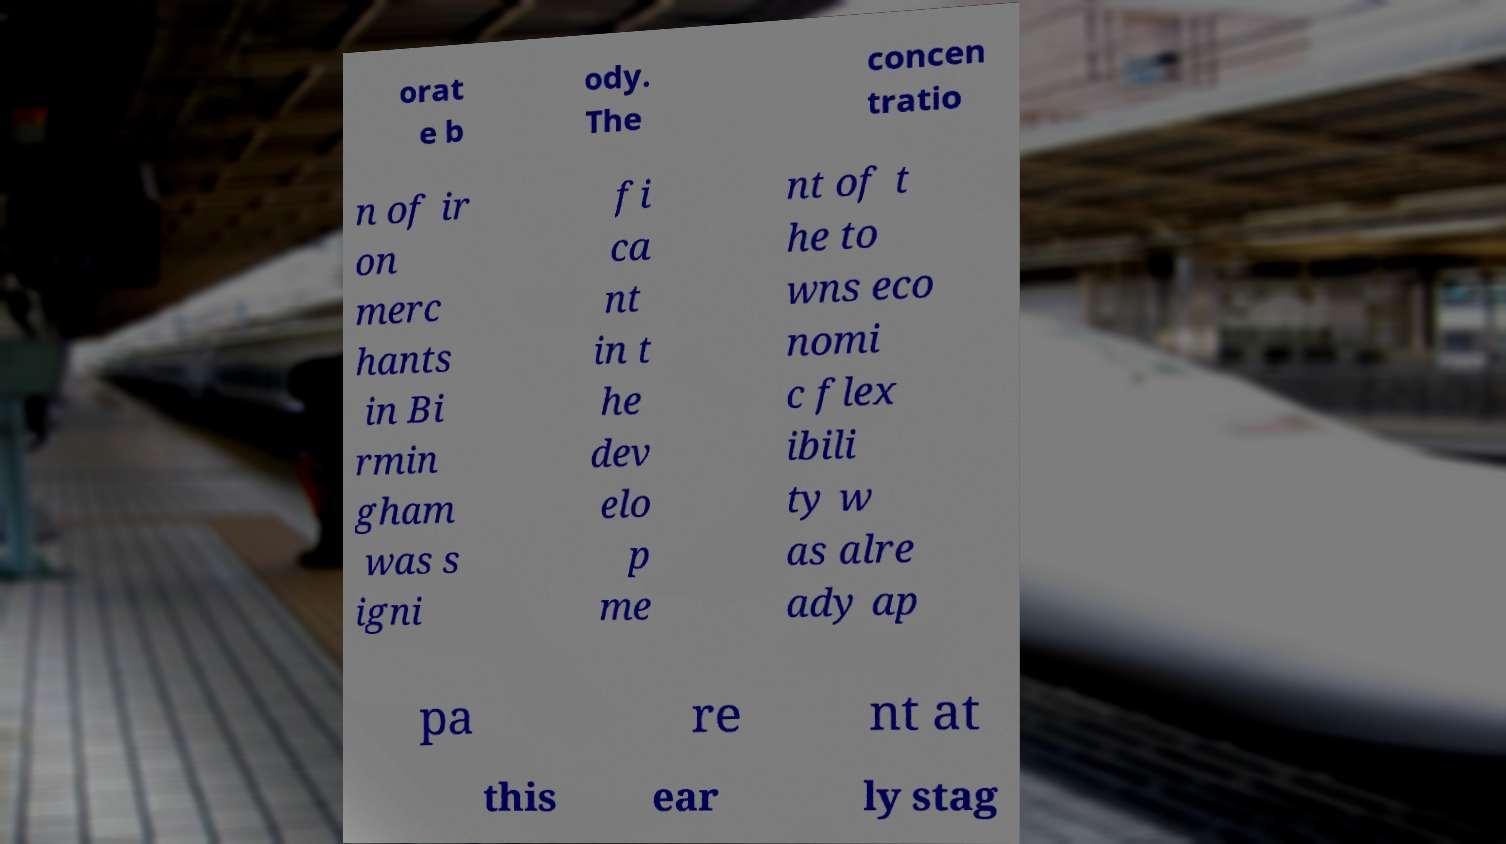Please read and relay the text visible in this image. What does it say? orat e b ody. The concen tratio n of ir on merc hants in Bi rmin gham was s igni fi ca nt in t he dev elo p me nt of t he to wns eco nomi c flex ibili ty w as alre ady ap pa re nt at this ear ly stag 